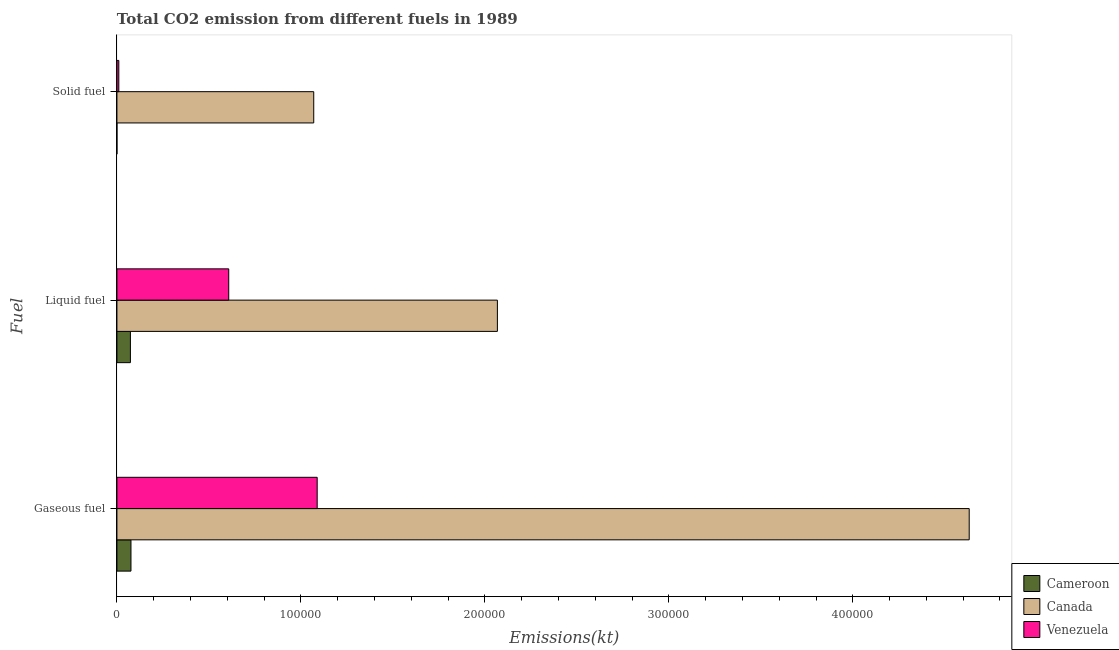How many different coloured bars are there?
Your answer should be compact. 3. Are the number of bars on each tick of the Y-axis equal?
Your answer should be very brief. Yes. How many bars are there on the 2nd tick from the top?
Offer a very short reply. 3. What is the label of the 3rd group of bars from the top?
Provide a short and direct response. Gaseous fuel. What is the amount of co2 emissions from liquid fuel in Canada?
Your response must be concise. 2.07e+05. Across all countries, what is the maximum amount of co2 emissions from liquid fuel?
Provide a succinct answer. 2.07e+05. Across all countries, what is the minimum amount of co2 emissions from solid fuel?
Offer a terse response. 3.67. In which country was the amount of co2 emissions from gaseous fuel maximum?
Your answer should be very brief. Canada. In which country was the amount of co2 emissions from gaseous fuel minimum?
Ensure brevity in your answer.  Cameroon. What is the total amount of co2 emissions from solid fuel in the graph?
Your answer should be compact. 1.08e+05. What is the difference between the amount of co2 emissions from solid fuel in Canada and that in Cameroon?
Make the answer very short. 1.07e+05. What is the difference between the amount of co2 emissions from solid fuel in Cameroon and the amount of co2 emissions from liquid fuel in Canada?
Your answer should be very brief. -2.07e+05. What is the average amount of co2 emissions from solid fuel per country?
Keep it short and to the point. 3.60e+04. What is the difference between the amount of co2 emissions from gaseous fuel and amount of co2 emissions from liquid fuel in Venezuela?
Make the answer very short. 4.81e+04. In how many countries, is the amount of co2 emissions from gaseous fuel greater than 320000 kt?
Your answer should be compact. 1. What is the ratio of the amount of co2 emissions from gaseous fuel in Canada to that in Cameroon?
Offer a very short reply. 60.65. Is the amount of co2 emissions from gaseous fuel in Venezuela less than that in Canada?
Your response must be concise. Yes. What is the difference between the highest and the second highest amount of co2 emissions from solid fuel?
Make the answer very short. 1.06e+05. What is the difference between the highest and the lowest amount of co2 emissions from liquid fuel?
Your response must be concise. 1.99e+05. In how many countries, is the amount of co2 emissions from gaseous fuel greater than the average amount of co2 emissions from gaseous fuel taken over all countries?
Provide a short and direct response. 1. What does the 1st bar from the top in Solid fuel represents?
Make the answer very short. Venezuela. What does the 3rd bar from the bottom in Liquid fuel represents?
Your answer should be very brief. Venezuela. Does the graph contain any zero values?
Keep it short and to the point. No. Does the graph contain grids?
Provide a succinct answer. No. What is the title of the graph?
Your answer should be compact. Total CO2 emission from different fuels in 1989. What is the label or title of the X-axis?
Offer a very short reply. Emissions(kt). What is the label or title of the Y-axis?
Offer a very short reply. Fuel. What is the Emissions(kt) in Cameroon in Gaseous fuel?
Offer a terse response. 7638.36. What is the Emissions(kt) in Canada in Gaseous fuel?
Your answer should be compact. 4.63e+05. What is the Emissions(kt) of Venezuela in Gaseous fuel?
Provide a short and direct response. 1.09e+05. What is the Emissions(kt) of Cameroon in Liquid fuel?
Make the answer very short. 7330.33. What is the Emissions(kt) in Canada in Liquid fuel?
Your answer should be very brief. 2.07e+05. What is the Emissions(kt) of Venezuela in Liquid fuel?
Give a very brief answer. 6.08e+04. What is the Emissions(kt) of Cameroon in Solid fuel?
Provide a succinct answer. 3.67. What is the Emissions(kt) in Canada in Solid fuel?
Provide a succinct answer. 1.07e+05. What is the Emissions(kt) in Venezuela in Solid fuel?
Ensure brevity in your answer.  1026.76. Across all Fuel, what is the maximum Emissions(kt) in Cameroon?
Give a very brief answer. 7638.36. Across all Fuel, what is the maximum Emissions(kt) of Canada?
Offer a terse response. 4.63e+05. Across all Fuel, what is the maximum Emissions(kt) of Venezuela?
Your answer should be very brief. 1.09e+05. Across all Fuel, what is the minimum Emissions(kt) of Cameroon?
Give a very brief answer. 3.67. Across all Fuel, what is the minimum Emissions(kt) in Canada?
Your answer should be compact. 1.07e+05. Across all Fuel, what is the minimum Emissions(kt) of Venezuela?
Make the answer very short. 1026.76. What is the total Emissions(kt) of Cameroon in the graph?
Your response must be concise. 1.50e+04. What is the total Emissions(kt) of Canada in the graph?
Ensure brevity in your answer.  7.77e+05. What is the total Emissions(kt) in Venezuela in the graph?
Ensure brevity in your answer.  1.71e+05. What is the difference between the Emissions(kt) in Cameroon in Gaseous fuel and that in Liquid fuel?
Provide a succinct answer. 308.03. What is the difference between the Emissions(kt) of Canada in Gaseous fuel and that in Liquid fuel?
Keep it short and to the point. 2.56e+05. What is the difference between the Emissions(kt) in Venezuela in Gaseous fuel and that in Liquid fuel?
Your answer should be compact. 4.81e+04. What is the difference between the Emissions(kt) in Cameroon in Gaseous fuel and that in Solid fuel?
Your response must be concise. 7634.69. What is the difference between the Emissions(kt) of Canada in Gaseous fuel and that in Solid fuel?
Keep it short and to the point. 3.56e+05. What is the difference between the Emissions(kt) of Venezuela in Gaseous fuel and that in Solid fuel?
Offer a terse response. 1.08e+05. What is the difference between the Emissions(kt) in Cameroon in Liquid fuel and that in Solid fuel?
Make the answer very short. 7326.67. What is the difference between the Emissions(kt) in Canada in Liquid fuel and that in Solid fuel?
Make the answer very short. 9.98e+04. What is the difference between the Emissions(kt) in Venezuela in Liquid fuel and that in Solid fuel?
Keep it short and to the point. 5.98e+04. What is the difference between the Emissions(kt) of Cameroon in Gaseous fuel and the Emissions(kt) of Canada in Liquid fuel?
Offer a very short reply. -1.99e+05. What is the difference between the Emissions(kt) in Cameroon in Gaseous fuel and the Emissions(kt) in Venezuela in Liquid fuel?
Ensure brevity in your answer.  -5.31e+04. What is the difference between the Emissions(kt) of Canada in Gaseous fuel and the Emissions(kt) of Venezuela in Liquid fuel?
Your answer should be compact. 4.02e+05. What is the difference between the Emissions(kt) of Cameroon in Gaseous fuel and the Emissions(kt) of Canada in Solid fuel?
Make the answer very short. -9.93e+04. What is the difference between the Emissions(kt) of Cameroon in Gaseous fuel and the Emissions(kt) of Venezuela in Solid fuel?
Ensure brevity in your answer.  6611.6. What is the difference between the Emissions(kt) in Canada in Gaseous fuel and the Emissions(kt) in Venezuela in Solid fuel?
Ensure brevity in your answer.  4.62e+05. What is the difference between the Emissions(kt) of Cameroon in Liquid fuel and the Emissions(kt) of Canada in Solid fuel?
Give a very brief answer. -9.97e+04. What is the difference between the Emissions(kt) of Cameroon in Liquid fuel and the Emissions(kt) of Venezuela in Solid fuel?
Your answer should be compact. 6303.57. What is the difference between the Emissions(kt) in Canada in Liquid fuel and the Emissions(kt) in Venezuela in Solid fuel?
Keep it short and to the point. 2.06e+05. What is the average Emissions(kt) in Cameroon per Fuel?
Your answer should be very brief. 4990.79. What is the average Emissions(kt) of Canada per Fuel?
Keep it short and to the point. 2.59e+05. What is the average Emissions(kt) in Venezuela per Fuel?
Your answer should be compact. 5.69e+04. What is the difference between the Emissions(kt) of Cameroon and Emissions(kt) of Canada in Gaseous fuel?
Provide a short and direct response. -4.56e+05. What is the difference between the Emissions(kt) in Cameroon and Emissions(kt) in Venezuela in Gaseous fuel?
Ensure brevity in your answer.  -1.01e+05. What is the difference between the Emissions(kt) in Canada and Emissions(kt) in Venezuela in Gaseous fuel?
Provide a short and direct response. 3.54e+05. What is the difference between the Emissions(kt) of Cameroon and Emissions(kt) of Canada in Liquid fuel?
Your response must be concise. -1.99e+05. What is the difference between the Emissions(kt) in Cameroon and Emissions(kt) in Venezuela in Liquid fuel?
Your answer should be very brief. -5.35e+04. What is the difference between the Emissions(kt) of Canada and Emissions(kt) of Venezuela in Liquid fuel?
Your response must be concise. 1.46e+05. What is the difference between the Emissions(kt) of Cameroon and Emissions(kt) of Canada in Solid fuel?
Your response must be concise. -1.07e+05. What is the difference between the Emissions(kt) of Cameroon and Emissions(kt) of Venezuela in Solid fuel?
Your answer should be compact. -1023.09. What is the difference between the Emissions(kt) of Canada and Emissions(kt) of Venezuela in Solid fuel?
Your answer should be very brief. 1.06e+05. What is the ratio of the Emissions(kt) in Cameroon in Gaseous fuel to that in Liquid fuel?
Provide a short and direct response. 1.04. What is the ratio of the Emissions(kt) in Canada in Gaseous fuel to that in Liquid fuel?
Make the answer very short. 2.24. What is the ratio of the Emissions(kt) of Venezuela in Gaseous fuel to that in Liquid fuel?
Ensure brevity in your answer.  1.79. What is the ratio of the Emissions(kt) in Cameroon in Gaseous fuel to that in Solid fuel?
Provide a short and direct response. 2083. What is the ratio of the Emissions(kt) of Canada in Gaseous fuel to that in Solid fuel?
Keep it short and to the point. 4.33. What is the ratio of the Emissions(kt) in Venezuela in Gaseous fuel to that in Solid fuel?
Your answer should be very brief. 106.02. What is the ratio of the Emissions(kt) of Cameroon in Liquid fuel to that in Solid fuel?
Give a very brief answer. 1999. What is the ratio of the Emissions(kt) in Canada in Liquid fuel to that in Solid fuel?
Provide a succinct answer. 1.93. What is the ratio of the Emissions(kt) of Venezuela in Liquid fuel to that in Solid fuel?
Keep it short and to the point. 59.2. What is the difference between the highest and the second highest Emissions(kt) of Cameroon?
Your response must be concise. 308.03. What is the difference between the highest and the second highest Emissions(kt) of Canada?
Make the answer very short. 2.56e+05. What is the difference between the highest and the second highest Emissions(kt) in Venezuela?
Give a very brief answer. 4.81e+04. What is the difference between the highest and the lowest Emissions(kt) in Cameroon?
Keep it short and to the point. 7634.69. What is the difference between the highest and the lowest Emissions(kt) of Canada?
Provide a short and direct response. 3.56e+05. What is the difference between the highest and the lowest Emissions(kt) in Venezuela?
Ensure brevity in your answer.  1.08e+05. 